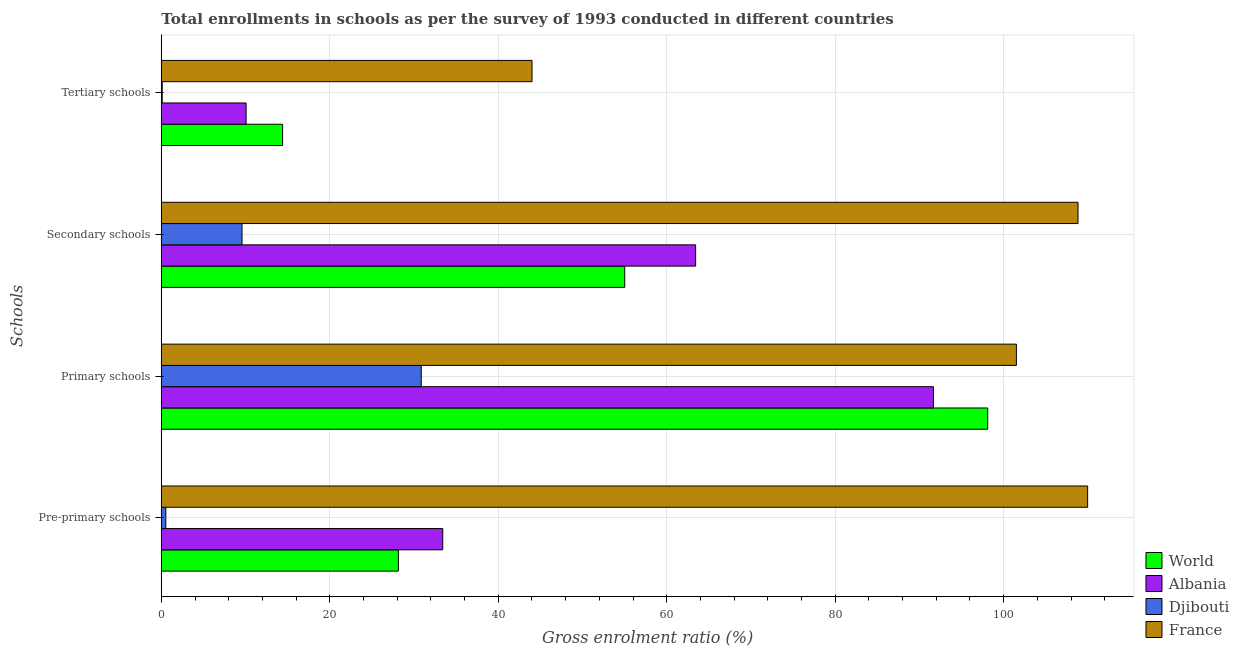How many groups of bars are there?
Ensure brevity in your answer.  4. Are the number of bars per tick equal to the number of legend labels?
Your answer should be compact. Yes. Are the number of bars on each tick of the Y-axis equal?
Give a very brief answer. Yes. How many bars are there on the 1st tick from the top?
Your response must be concise. 4. What is the label of the 1st group of bars from the top?
Make the answer very short. Tertiary schools. What is the gross enrolment ratio in secondary schools in Djibouti?
Your answer should be very brief. 9.58. Across all countries, what is the maximum gross enrolment ratio in pre-primary schools?
Make the answer very short. 109.97. Across all countries, what is the minimum gross enrolment ratio in secondary schools?
Offer a terse response. 9.58. In which country was the gross enrolment ratio in primary schools minimum?
Offer a terse response. Djibouti. What is the total gross enrolment ratio in tertiary schools in the graph?
Offer a terse response. 68.58. What is the difference between the gross enrolment ratio in pre-primary schools in France and that in World?
Give a very brief answer. 81.83. What is the difference between the gross enrolment ratio in pre-primary schools in World and the gross enrolment ratio in primary schools in Djibouti?
Provide a succinct answer. -2.72. What is the average gross enrolment ratio in secondary schools per country?
Ensure brevity in your answer.  59.21. What is the difference between the gross enrolment ratio in tertiary schools and gross enrolment ratio in primary schools in Albania?
Offer a terse response. -81.59. What is the ratio of the gross enrolment ratio in primary schools in World to that in Albania?
Your response must be concise. 1.07. Is the gross enrolment ratio in primary schools in France less than that in Albania?
Your answer should be compact. No. Is the difference between the gross enrolment ratio in secondary schools in Djibouti and Albania greater than the difference between the gross enrolment ratio in pre-primary schools in Djibouti and Albania?
Offer a very short reply. No. What is the difference between the highest and the second highest gross enrolment ratio in tertiary schools?
Your response must be concise. 29.61. What is the difference between the highest and the lowest gross enrolment ratio in primary schools?
Offer a very short reply. 70.65. Is the sum of the gross enrolment ratio in primary schools in World and France greater than the maximum gross enrolment ratio in pre-primary schools across all countries?
Offer a terse response. Yes. What does the 3rd bar from the top in Secondary schools represents?
Your answer should be very brief. Albania. What does the 3rd bar from the bottom in Primary schools represents?
Keep it short and to the point. Djibouti. Is it the case that in every country, the sum of the gross enrolment ratio in pre-primary schools and gross enrolment ratio in primary schools is greater than the gross enrolment ratio in secondary schools?
Ensure brevity in your answer.  Yes. How many bars are there?
Keep it short and to the point. 16. Are all the bars in the graph horizontal?
Your response must be concise. Yes. How many countries are there in the graph?
Keep it short and to the point. 4. What is the difference between two consecutive major ticks on the X-axis?
Provide a succinct answer. 20. Does the graph contain grids?
Make the answer very short. Yes. How are the legend labels stacked?
Ensure brevity in your answer.  Vertical. What is the title of the graph?
Your answer should be very brief. Total enrollments in schools as per the survey of 1993 conducted in different countries. What is the label or title of the X-axis?
Ensure brevity in your answer.  Gross enrolment ratio (%). What is the label or title of the Y-axis?
Provide a succinct answer. Schools. What is the Gross enrolment ratio (%) of World in Pre-primary schools?
Your answer should be very brief. 28.14. What is the Gross enrolment ratio (%) of Albania in Pre-primary schools?
Provide a succinct answer. 33.41. What is the Gross enrolment ratio (%) of Djibouti in Pre-primary schools?
Keep it short and to the point. 0.54. What is the Gross enrolment ratio (%) of France in Pre-primary schools?
Your answer should be very brief. 109.97. What is the Gross enrolment ratio (%) in World in Primary schools?
Your response must be concise. 98.11. What is the Gross enrolment ratio (%) in Albania in Primary schools?
Offer a very short reply. 91.66. What is the Gross enrolment ratio (%) of Djibouti in Primary schools?
Make the answer very short. 30.86. What is the Gross enrolment ratio (%) of France in Primary schools?
Your answer should be compact. 101.51. What is the Gross enrolment ratio (%) in World in Secondary schools?
Keep it short and to the point. 55.01. What is the Gross enrolment ratio (%) in Albania in Secondary schools?
Provide a succinct answer. 63.43. What is the Gross enrolment ratio (%) of Djibouti in Secondary schools?
Ensure brevity in your answer.  9.58. What is the Gross enrolment ratio (%) in France in Secondary schools?
Offer a terse response. 108.82. What is the Gross enrolment ratio (%) of World in Tertiary schools?
Your answer should be very brief. 14.4. What is the Gross enrolment ratio (%) in Albania in Tertiary schools?
Give a very brief answer. 10.07. What is the Gross enrolment ratio (%) in Djibouti in Tertiary schools?
Ensure brevity in your answer.  0.11. What is the Gross enrolment ratio (%) of France in Tertiary schools?
Provide a succinct answer. 44.01. Across all Schools, what is the maximum Gross enrolment ratio (%) in World?
Keep it short and to the point. 98.11. Across all Schools, what is the maximum Gross enrolment ratio (%) of Albania?
Give a very brief answer. 91.66. Across all Schools, what is the maximum Gross enrolment ratio (%) in Djibouti?
Your answer should be very brief. 30.86. Across all Schools, what is the maximum Gross enrolment ratio (%) in France?
Provide a short and direct response. 109.97. Across all Schools, what is the minimum Gross enrolment ratio (%) in World?
Provide a succinct answer. 14.4. Across all Schools, what is the minimum Gross enrolment ratio (%) of Albania?
Provide a short and direct response. 10.07. Across all Schools, what is the minimum Gross enrolment ratio (%) in Djibouti?
Make the answer very short. 0.11. Across all Schools, what is the minimum Gross enrolment ratio (%) in France?
Offer a terse response. 44.01. What is the total Gross enrolment ratio (%) of World in the graph?
Your response must be concise. 195.66. What is the total Gross enrolment ratio (%) in Albania in the graph?
Offer a terse response. 198.56. What is the total Gross enrolment ratio (%) of Djibouti in the graph?
Ensure brevity in your answer.  41.08. What is the total Gross enrolment ratio (%) of France in the graph?
Your response must be concise. 364.31. What is the difference between the Gross enrolment ratio (%) in World in Pre-primary schools and that in Primary schools?
Your answer should be very brief. -69.96. What is the difference between the Gross enrolment ratio (%) of Albania in Pre-primary schools and that in Primary schools?
Offer a terse response. -58.25. What is the difference between the Gross enrolment ratio (%) of Djibouti in Pre-primary schools and that in Primary schools?
Your response must be concise. -30.32. What is the difference between the Gross enrolment ratio (%) in France in Pre-primary schools and that in Primary schools?
Make the answer very short. 8.46. What is the difference between the Gross enrolment ratio (%) of World in Pre-primary schools and that in Secondary schools?
Your answer should be very brief. -26.87. What is the difference between the Gross enrolment ratio (%) in Albania in Pre-primary schools and that in Secondary schools?
Ensure brevity in your answer.  -30.02. What is the difference between the Gross enrolment ratio (%) of Djibouti in Pre-primary schools and that in Secondary schools?
Offer a terse response. -9.05. What is the difference between the Gross enrolment ratio (%) of France in Pre-primary schools and that in Secondary schools?
Keep it short and to the point. 1.14. What is the difference between the Gross enrolment ratio (%) in World in Pre-primary schools and that in Tertiary schools?
Ensure brevity in your answer.  13.74. What is the difference between the Gross enrolment ratio (%) in Albania in Pre-primary schools and that in Tertiary schools?
Provide a succinct answer. 23.34. What is the difference between the Gross enrolment ratio (%) in Djibouti in Pre-primary schools and that in Tertiary schools?
Your answer should be compact. 0.43. What is the difference between the Gross enrolment ratio (%) in France in Pre-primary schools and that in Tertiary schools?
Your answer should be very brief. 65.96. What is the difference between the Gross enrolment ratio (%) in World in Primary schools and that in Secondary schools?
Make the answer very short. 43.09. What is the difference between the Gross enrolment ratio (%) of Albania in Primary schools and that in Secondary schools?
Provide a short and direct response. 28.23. What is the difference between the Gross enrolment ratio (%) of Djibouti in Primary schools and that in Secondary schools?
Make the answer very short. 21.28. What is the difference between the Gross enrolment ratio (%) of France in Primary schools and that in Secondary schools?
Make the answer very short. -7.31. What is the difference between the Gross enrolment ratio (%) in World in Primary schools and that in Tertiary schools?
Make the answer very short. 83.71. What is the difference between the Gross enrolment ratio (%) of Albania in Primary schools and that in Tertiary schools?
Give a very brief answer. 81.59. What is the difference between the Gross enrolment ratio (%) of Djibouti in Primary schools and that in Tertiary schools?
Your answer should be very brief. 30.75. What is the difference between the Gross enrolment ratio (%) of France in Primary schools and that in Tertiary schools?
Provide a short and direct response. 57.5. What is the difference between the Gross enrolment ratio (%) in World in Secondary schools and that in Tertiary schools?
Your answer should be compact. 40.61. What is the difference between the Gross enrolment ratio (%) of Albania in Secondary schools and that in Tertiary schools?
Keep it short and to the point. 53.36. What is the difference between the Gross enrolment ratio (%) of Djibouti in Secondary schools and that in Tertiary schools?
Ensure brevity in your answer.  9.48. What is the difference between the Gross enrolment ratio (%) in France in Secondary schools and that in Tertiary schools?
Ensure brevity in your answer.  64.82. What is the difference between the Gross enrolment ratio (%) of World in Pre-primary schools and the Gross enrolment ratio (%) of Albania in Primary schools?
Ensure brevity in your answer.  -63.52. What is the difference between the Gross enrolment ratio (%) of World in Pre-primary schools and the Gross enrolment ratio (%) of Djibouti in Primary schools?
Make the answer very short. -2.72. What is the difference between the Gross enrolment ratio (%) in World in Pre-primary schools and the Gross enrolment ratio (%) in France in Primary schools?
Provide a short and direct response. -73.37. What is the difference between the Gross enrolment ratio (%) of Albania in Pre-primary schools and the Gross enrolment ratio (%) of Djibouti in Primary schools?
Offer a very short reply. 2.55. What is the difference between the Gross enrolment ratio (%) in Albania in Pre-primary schools and the Gross enrolment ratio (%) in France in Primary schools?
Make the answer very short. -68.1. What is the difference between the Gross enrolment ratio (%) of Djibouti in Pre-primary schools and the Gross enrolment ratio (%) of France in Primary schools?
Provide a succinct answer. -100.97. What is the difference between the Gross enrolment ratio (%) of World in Pre-primary schools and the Gross enrolment ratio (%) of Albania in Secondary schools?
Give a very brief answer. -35.29. What is the difference between the Gross enrolment ratio (%) of World in Pre-primary schools and the Gross enrolment ratio (%) of Djibouti in Secondary schools?
Keep it short and to the point. 18.56. What is the difference between the Gross enrolment ratio (%) in World in Pre-primary schools and the Gross enrolment ratio (%) in France in Secondary schools?
Keep it short and to the point. -80.68. What is the difference between the Gross enrolment ratio (%) of Albania in Pre-primary schools and the Gross enrolment ratio (%) of Djibouti in Secondary schools?
Your response must be concise. 23.83. What is the difference between the Gross enrolment ratio (%) in Albania in Pre-primary schools and the Gross enrolment ratio (%) in France in Secondary schools?
Give a very brief answer. -75.42. What is the difference between the Gross enrolment ratio (%) in Djibouti in Pre-primary schools and the Gross enrolment ratio (%) in France in Secondary schools?
Ensure brevity in your answer.  -108.29. What is the difference between the Gross enrolment ratio (%) in World in Pre-primary schools and the Gross enrolment ratio (%) in Albania in Tertiary schools?
Give a very brief answer. 18.08. What is the difference between the Gross enrolment ratio (%) of World in Pre-primary schools and the Gross enrolment ratio (%) of Djibouti in Tertiary schools?
Offer a terse response. 28.04. What is the difference between the Gross enrolment ratio (%) in World in Pre-primary schools and the Gross enrolment ratio (%) in France in Tertiary schools?
Provide a succinct answer. -15.87. What is the difference between the Gross enrolment ratio (%) of Albania in Pre-primary schools and the Gross enrolment ratio (%) of Djibouti in Tertiary schools?
Offer a very short reply. 33.3. What is the difference between the Gross enrolment ratio (%) in Albania in Pre-primary schools and the Gross enrolment ratio (%) in France in Tertiary schools?
Give a very brief answer. -10.6. What is the difference between the Gross enrolment ratio (%) in Djibouti in Pre-primary schools and the Gross enrolment ratio (%) in France in Tertiary schools?
Provide a succinct answer. -43.47. What is the difference between the Gross enrolment ratio (%) of World in Primary schools and the Gross enrolment ratio (%) of Albania in Secondary schools?
Your response must be concise. 34.68. What is the difference between the Gross enrolment ratio (%) of World in Primary schools and the Gross enrolment ratio (%) of Djibouti in Secondary schools?
Your response must be concise. 88.52. What is the difference between the Gross enrolment ratio (%) of World in Primary schools and the Gross enrolment ratio (%) of France in Secondary schools?
Ensure brevity in your answer.  -10.72. What is the difference between the Gross enrolment ratio (%) in Albania in Primary schools and the Gross enrolment ratio (%) in Djibouti in Secondary schools?
Offer a terse response. 82.08. What is the difference between the Gross enrolment ratio (%) in Albania in Primary schools and the Gross enrolment ratio (%) in France in Secondary schools?
Ensure brevity in your answer.  -17.17. What is the difference between the Gross enrolment ratio (%) in Djibouti in Primary schools and the Gross enrolment ratio (%) in France in Secondary schools?
Give a very brief answer. -77.97. What is the difference between the Gross enrolment ratio (%) of World in Primary schools and the Gross enrolment ratio (%) of Albania in Tertiary schools?
Provide a succinct answer. 88.04. What is the difference between the Gross enrolment ratio (%) in World in Primary schools and the Gross enrolment ratio (%) in Djibouti in Tertiary schools?
Your response must be concise. 98. What is the difference between the Gross enrolment ratio (%) of World in Primary schools and the Gross enrolment ratio (%) of France in Tertiary schools?
Offer a terse response. 54.1. What is the difference between the Gross enrolment ratio (%) in Albania in Primary schools and the Gross enrolment ratio (%) in Djibouti in Tertiary schools?
Give a very brief answer. 91.55. What is the difference between the Gross enrolment ratio (%) of Albania in Primary schools and the Gross enrolment ratio (%) of France in Tertiary schools?
Offer a very short reply. 47.65. What is the difference between the Gross enrolment ratio (%) of Djibouti in Primary schools and the Gross enrolment ratio (%) of France in Tertiary schools?
Offer a terse response. -13.15. What is the difference between the Gross enrolment ratio (%) of World in Secondary schools and the Gross enrolment ratio (%) of Albania in Tertiary schools?
Provide a succinct answer. 44.95. What is the difference between the Gross enrolment ratio (%) in World in Secondary schools and the Gross enrolment ratio (%) in Djibouti in Tertiary schools?
Provide a succinct answer. 54.91. What is the difference between the Gross enrolment ratio (%) of World in Secondary schools and the Gross enrolment ratio (%) of France in Tertiary schools?
Give a very brief answer. 11. What is the difference between the Gross enrolment ratio (%) in Albania in Secondary schools and the Gross enrolment ratio (%) in Djibouti in Tertiary schools?
Your response must be concise. 63.32. What is the difference between the Gross enrolment ratio (%) in Albania in Secondary schools and the Gross enrolment ratio (%) in France in Tertiary schools?
Your answer should be very brief. 19.42. What is the difference between the Gross enrolment ratio (%) of Djibouti in Secondary schools and the Gross enrolment ratio (%) of France in Tertiary schools?
Make the answer very short. -34.43. What is the average Gross enrolment ratio (%) of World per Schools?
Give a very brief answer. 48.91. What is the average Gross enrolment ratio (%) of Albania per Schools?
Your answer should be very brief. 49.64. What is the average Gross enrolment ratio (%) in Djibouti per Schools?
Your answer should be very brief. 10.27. What is the average Gross enrolment ratio (%) of France per Schools?
Give a very brief answer. 91.08. What is the difference between the Gross enrolment ratio (%) in World and Gross enrolment ratio (%) in Albania in Pre-primary schools?
Ensure brevity in your answer.  -5.27. What is the difference between the Gross enrolment ratio (%) of World and Gross enrolment ratio (%) of Djibouti in Pre-primary schools?
Keep it short and to the point. 27.61. What is the difference between the Gross enrolment ratio (%) of World and Gross enrolment ratio (%) of France in Pre-primary schools?
Provide a short and direct response. -81.83. What is the difference between the Gross enrolment ratio (%) of Albania and Gross enrolment ratio (%) of Djibouti in Pre-primary schools?
Make the answer very short. 32.87. What is the difference between the Gross enrolment ratio (%) in Albania and Gross enrolment ratio (%) in France in Pre-primary schools?
Your answer should be very brief. -76.56. What is the difference between the Gross enrolment ratio (%) in Djibouti and Gross enrolment ratio (%) in France in Pre-primary schools?
Provide a succinct answer. -109.43. What is the difference between the Gross enrolment ratio (%) in World and Gross enrolment ratio (%) in Albania in Primary schools?
Provide a succinct answer. 6.45. What is the difference between the Gross enrolment ratio (%) of World and Gross enrolment ratio (%) of Djibouti in Primary schools?
Ensure brevity in your answer.  67.25. What is the difference between the Gross enrolment ratio (%) of World and Gross enrolment ratio (%) of France in Primary schools?
Offer a very short reply. -3.4. What is the difference between the Gross enrolment ratio (%) of Albania and Gross enrolment ratio (%) of Djibouti in Primary schools?
Give a very brief answer. 60.8. What is the difference between the Gross enrolment ratio (%) of Albania and Gross enrolment ratio (%) of France in Primary schools?
Provide a short and direct response. -9.85. What is the difference between the Gross enrolment ratio (%) in Djibouti and Gross enrolment ratio (%) in France in Primary schools?
Your answer should be very brief. -70.65. What is the difference between the Gross enrolment ratio (%) in World and Gross enrolment ratio (%) in Albania in Secondary schools?
Provide a short and direct response. -8.42. What is the difference between the Gross enrolment ratio (%) in World and Gross enrolment ratio (%) in Djibouti in Secondary schools?
Your response must be concise. 45.43. What is the difference between the Gross enrolment ratio (%) in World and Gross enrolment ratio (%) in France in Secondary schools?
Ensure brevity in your answer.  -53.81. What is the difference between the Gross enrolment ratio (%) in Albania and Gross enrolment ratio (%) in Djibouti in Secondary schools?
Provide a succinct answer. 53.85. What is the difference between the Gross enrolment ratio (%) of Albania and Gross enrolment ratio (%) of France in Secondary schools?
Provide a short and direct response. -45.39. What is the difference between the Gross enrolment ratio (%) in Djibouti and Gross enrolment ratio (%) in France in Secondary schools?
Make the answer very short. -99.24. What is the difference between the Gross enrolment ratio (%) in World and Gross enrolment ratio (%) in Albania in Tertiary schools?
Give a very brief answer. 4.33. What is the difference between the Gross enrolment ratio (%) in World and Gross enrolment ratio (%) in Djibouti in Tertiary schools?
Offer a very short reply. 14.29. What is the difference between the Gross enrolment ratio (%) in World and Gross enrolment ratio (%) in France in Tertiary schools?
Make the answer very short. -29.61. What is the difference between the Gross enrolment ratio (%) of Albania and Gross enrolment ratio (%) of Djibouti in Tertiary schools?
Give a very brief answer. 9.96. What is the difference between the Gross enrolment ratio (%) in Albania and Gross enrolment ratio (%) in France in Tertiary schools?
Make the answer very short. -33.94. What is the difference between the Gross enrolment ratio (%) in Djibouti and Gross enrolment ratio (%) in France in Tertiary schools?
Give a very brief answer. -43.9. What is the ratio of the Gross enrolment ratio (%) of World in Pre-primary schools to that in Primary schools?
Offer a very short reply. 0.29. What is the ratio of the Gross enrolment ratio (%) of Albania in Pre-primary schools to that in Primary schools?
Make the answer very short. 0.36. What is the ratio of the Gross enrolment ratio (%) of Djibouti in Pre-primary schools to that in Primary schools?
Offer a very short reply. 0.02. What is the ratio of the Gross enrolment ratio (%) of World in Pre-primary schools to that in Secondary schools?
Make the answer very short. 0.51. What is the ratio of the Gross enrolment ratio (%) in Albania in Pre-primary schools to that in Secondary schools?
Keep it short and to the point. 0.53. What is the ratio of the Gross enrolment ratio (%) in Djibouti in Pre-primary schools to that in Secondary schools?
Give a very brief answer. 0.06. What is the ratio of the Gross enrolment ratio (%) of France in Pre-primary schools to that in Secondary schools?
Make the answer very short. 1.01. What is the ratio of the Gross enrolment ratio (%) of World in Pre-primary schools to that in Tertiary schools?
Keep it short and to the point. 1.95. What is the ratio of the Gross enrolment ratio (%) in Albania in Pre-primary schools to that in Tertiary schools?
Your answer should be very brief. 3.32. What is the ratio of the Gross enrolment ratio (%) in Djibouti in Pre-primary schools to that in Tertiary schools?
Give a very brief answer. 5.06. What is the ratio of the Gross enrolment ratio (%) in France in Pre-primary schools to that in Tertiary schools?
Your answer should be very brief. 2.5. What is the ratio of the Gross enrolment ratio (%) of World in Primary schools to that in Secondary schools?
Offer a very short reply. 1.78. What is the ratio of the Gross enrolment ratio (%) in Albania in Primary schools to that in Secondary schools?
Keep it short and to the point. 1.45. What is the ratio of the Gross enrolment ratio (%) in Djibouti in Primary schools to that in Secondary schools?
Ensure brevity in your answer.  3.22. What is the ratio of the Gross enrolment ratio (%) in France in Primary schools to that in Secondary schools?
Give a very brief answer. 0.93. What is the ratio of the Gross enrolment ratio (%) of World in Primary schools to that in Tertiary schools?
Your answer should be very brief. 6.81. What is the ratio of the Gross enrolment ratio (%) of Albania in Primary schools to that in Tertiary schools?
Keep it short and to the point. 9.11. What is the ratio of the Gross enrolment ratio (%) in Djibouti in Primary schools to that in Tertiary schools?
Make the answer very short. 291.11. What is the ratio of the Gross enrolment ratio (%) of France in Primary schools to that in Tertiary schools?
Keep it short and to the point. 2.31. What is the ratio of the Gross enrolment ratio (%) of World in Secondary schools to that in Tertiary schools?
Keep it short and to the point. 3.82. What is the ratio of the Gross enrolment ratio (%) of Albania in Secondary schools to that in Tertiary schools?
Provide a short and direct response. 6.3. What is the ratio of the Gross enrolment ratio (%) in Djibouti in Secondary schools to that in Tertiary schools?
Offer a very short reply. 90.39. What is the ratio of the Gross enrolment ratio (%) in France in Secondary schools to that in Tertiary schools?
Offer a very short reply. 2.47. What is the difference between the highest and the second highest Gross enrolment ratio (%) in World?
Offer a very short reply. 43.09. What is the difference between the highest and the second highest Gross enrolment ratio (%) of Albania?
Give a very brief answer. 28.23. What is the difference between the highest and the second highest Gross enrolment ratio (%) in Djibouti?
Your response must be concise. 21.28. What is the difference between the highest and the second highest Gross enrolment ratio (%) of France?
Make the answer very short. 1.14. What is the difference between the highest and the lowest Gross enrolment ratio (%) of World?
Your answer should be very brief. 83.71. What is the difference between the highest and the lowest Gross enrolment ratio (%) in Albania?
Make the answer very short. 81.59. What is the difference between the highest and the lowest Gross enrolment ratio (%) of Djibouti?
Offer a terse response. 30.75. What is the difference between the highest and the lowest Gross enrolment ratio (%) in France?
Make the answer very short. 65.96. 